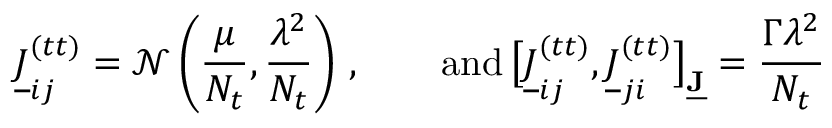<formula> <loc_0><loc_0><loc_500><loc_500>\underline { J } _ { i j } ^ { ( t t ) } = \mathcal { N } \left ( \frac { \mu } { N _ { t } } , \frac { \lambda ^ { 2 } } { N _ { t } } \right ) \, , \quad a n d \, \left [ \underline { J } _ { i j } ^ { ( t t ) } , \underline { J } _ { j i } ^ { ( t t ) } \right ] _ { \underline { J } } = \frac { \Gamma \lambda ^ { 2 } } { N _ { t } }</formula> 